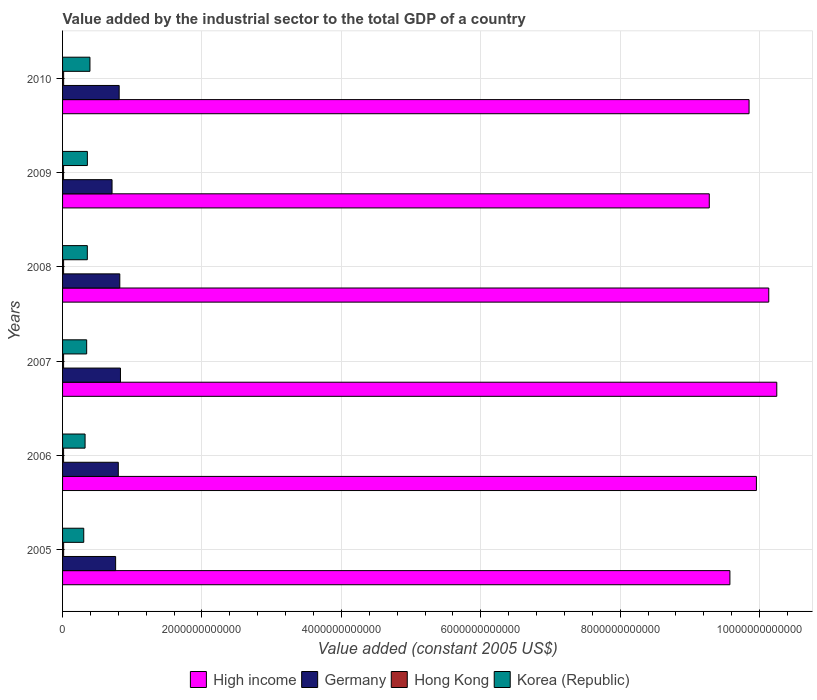How many different coloured bars are there?
Keep it short and to the point. 4. Are the number of bars per tick equal to the number of legend labels?
Provide a succinct answer. Yes. Are the number of bars on each tick of the Y-axis equal?
Your response must be concise. Yes. What is the label of the 4th group of bars from the top?
Your response must be concise. 2007. In how many cases, is the number of bars for a given year not equal to the number of legend labels?
Your response must be concise. 0. What is the value added by the industrial sector in Germany in 2009?
Keep it short and to the point. 7.10e+11. Across all years, what is the maximum value added by the industrial sector in High income?
Offer a terse response. 1.02e+13. Across all years, what is the minimum value added by the industrial sector in High income?
Your answer should be very brief. 9.28e+12. What is the total value added by the industrial sector in Hong Kong in the graph?
Give a very brief answer. 8.97e+1. What is the difference between the value added by the industrial sector in Hong Kong in 2005 and that in 2010?
Keep it short and to the point. -7.29e+07. What is the difference between the value added by the industrial sector in High income in 2009 and the value added by the industrial sector in Hong Kong in 2007?
Keep it short and to the point. 9.26e+12. What is the average value added by the industrial sector in Korea (Republic) per year?
Make the answer very short. 3.46e+11. In the year 2007, what is the difference between the value added by the industrial sector in High income and value added by the industrial sector in Germany?
Give a very brief answer. 9.42e+12. In how many years, is the value added by the industrial sector in Germany greater than 5600000000000 US$?
Provide a short and direct response. 0. What is the ratio of the value added by the industrial sector in Korea (Republic) in 2006 to that in 2008?
Give a very brief answer. 0.91. Is the difference between the value added by the industrial sector in High income in 2007 and 2008 greater than the difference between the value added by the industrial sector in Germany in 2007 and 2008?
Offer a terse response. Yes. What is the difference between the highest and the second highest value added by the industrial sector in High income?
Your answer should be compact. 1.15e+11. What is the difference between the highest and the lowest value added by the industrial sector in High income?
Offer a terse response. 9.68e+11. In how many years, is the value added by the industrial sector in Hong Kong greater than the average value added by the industrial sector in Hong Kong taken over all years?
Offer a terse response. 3. Is the sum of the value added by the industrial sector in Germany in 2008 and 2009 greater than the maximum value added by the industrial sector in Korea (Republic) across all years?
Your response must be concise. Yes. What does the 2nd bar from the top in 2006 represents?
Provide a short and direct response. Hong Kong. What does the 2nd bar from the bottom in 2006 represents?
Your answer should be very brief. Germany. What is the difference between two consecutive major ticks on the X-axis?
Your answer should be compact. 2.00e+12. Are the values on the major ticks of X-axis written in scientific E-notation?
Keep it short and to the point. No. Does the graph contain any zero values?
Make the answer very short. No. Where does the legend appear in the graph?
Offer a very short reply. Bottom center. How many legend labels are there?
Offer a very short reply. 4. What is the title of the graph?
Provide a short and direct response. Value added by the industrial sector to the total GDP of a country. What is the label or title of the X-axis?
Provide a short and direct response. Value added (constant 2005 US$). What is the Value added (constant 2005 US$) in High income in 2005?
Offer a terse response. 9.57e+12. What is the Value added (constant 2005 US$) in Germany in 2005?
Your answer should be very brief. 7.61e+11. What is the Value added (constant 2005 US$) in Hong Kong in 2005?
Make the answer very short. 1.54e+1. What is the Value added (constant 2005 US$) of Korea (Republic) in 2005?
Your answer should be compact. 3.04e+11. What is the Value added (constant 2005 US$) in High income in 2006?
Make the answer very short. 9.95e+12. What is the Value added (constant 2005 US$) of Germany in 2006?
Give a very brief answer. 8.00e+11. What is the Value added (constant 2005 US$) in Hong Kong in 2006?
Give a very brief answer. 1.48e+1. What is the Value added (constant 2005 US$) of Korea (Republic) in 2006?
Ensure brevity in your answer.  3.23e+11. What is the Value added (constant 2005 US$) of High income in 2007?
Keep it short and to the point. 1.02e+13. What is the Value added (constant 2005 US$) of Germany in 2007?
Offer a terse response. 8.31e+11. What is the Value added (constant 2005 US$) in Hong Kong in 2007?
Offer a terse response. 1.48e+1. What is the Value added (constant 2005 US$) of Korea (Republic) in 2007?
Your response must be concise. 3.46e+11. What is the Value added (constant 2005 US$) in High income in 2008?
Your answer should be compact. 1.01e+13. What is the Value added (constant 2005 US$) in Germany in 2008?
Offer a terse response. 8.21e+11. What is the Value added (constant 2005 US$) in Hong Kong in 2008?
Give a very brief answer. 1.51e+1. What is the Value added (constant 2005 US$) of Korea (Republic) in 2008?
Make the answer very short. 3.55e+11. What is the Value added (constant 2005 US$) of High income in 2009?
Offer a terse response. 9.28e+12. What is the Value added (constant 2005 US$) in Germany in 2009?
Offer a very short reply. 7.10e+11. What is the Value added (constant 2005 US$) in Hong Kong in 2009?
Your answer should be very brief. 1.43e+1. What is the Value added (constant 2005 US$) of Korea (Republic) in 2009?
Your response must be concise. 3.56e+11. What is the Value added (constant 2005 US$) of High income in 2010?
Your answer should be very brief. 9.85e+12. What is the Value added (constant 2005 US$) of Germany in 2010?
Offer a terse response. 8.12e+11. What is the Value added (constant 2005 US$) in Hong Kong in 2010?
Provide a succinct answer. 1.54e+1. What is the Value added (constant 2005 US$) in Korea (Republic) in 2010?
Your answer should be very brief. 3.93e+11. Across all years, what is the maximum Value added (constant 2005 US$) in High income?
Ensure brevity in your answer.  1.02e+13. Across all years, what is the maximum Value added (constant 2005 US$) of Germany?
Offer a very short reply. 8.31e+11. Across all years, what is the maximum Value added (constant 2005 US$) in Hong Kong?
Ensure brevity in your answer.  1.54e+1. Across all years, what is the maximum Value added (constant 2005 US$) in Korea (Republic)?
Ensure brevity in your answer.  3.93e+11. Across all years, what is the minimum Value added (constant 2005 US$) in High income?
Your answer should be compact. 9.28e+12. Across all years, what is the minimum Value added (constant 2005 US$) of Germany?
Give a very brief answer. 7.10e+11. Across all years, what is the minimum Value added (constant 2005 US$) of Hong Kong?
Offer a very short reply. 1.43e+1. Across all years, what is the minimum Value added (constant 2005 US$) of Korea (Republic)?
Your response must be concise. 3.04e+11. What is the total Value added (constant 2005 US$) of High income in the graph?
Keep it short and to the point. 5.90e+13. What is the total Value added (constant 2005 US$) in Germany in the graph?
Ensure brevity in your answer.  4.73e+12. What is the total Value added (constant 2005 US$) of Hong Kong in the graph?
Your answer should be very brief. 8.97e+1. What is the total Value added (constant 2005 US$) in Korea (Republic) in the graph?
Give a very brief answer. 2.08e+12. What is the difference between the Value added (constant 2005 US$) in High income in 2005 and that in 2006?
Your answer should be compact. -3.80e+11. What is the difference between the Value added (constant 2005 US$) in Germany in 2005 and that in 2006?
Provide a succinct answer. -3.83e+1. What is the difference between the Value added (constant 2005 US$) of Hong Kong in 2005 and that in 2006?
Your response must be concise. 5.48e+08. What is the difference between the Value added (constant 2005 US$) of Korea (Republic) in 2005 and that in 2006?
Your answer should be compact. -1.90e+1. What is the difference between the Value added (constant 2005 US$) of High income in 2005 and that in 2007?
Your response must be concise. -6.73e+11. What is the difference between the Value added (constant 2005 US$) in Germany in 2005 and that in 2007?
Give a very brief answer. -6.95e+1. What is the difference between the Value added (constant 2005 US$) in Hong Kong in 2005 and that in 2007?
Make the answer very short. 5.95e+08. What is the difference between the Value added (constant 2005 US$) of Korea (Republic) in 2005 and that in 2007?
Your answer should be very brief. -4.20e+1. What is the difference between the Value added (constant 2005 US$) of High income in 2005 and that in 2008?
Provide a short and direct response. -5.58e+11. What is the difference between the Value added (constant 2005 US$) of Germany in 2005 and that in 2008?
Give a very brief answer. -5.98e+1. What is the difference between the Value added (constant 2005 US$) of Hong Kong in 2005 and that in 2008?
Ensure brevity in your answer.  2.79e+08. What is the difference between the Value added (constant 2005 US$) of Korea (Republic) in 2005 and that in 2008?
Offer a terse response. -5.13e+1. What is the difference between the Value added (constant 2005 US$) of High income in 2005 and that in 2009?
Your response must be concise. 2.96e+11. What is the difference between the Value added (constant 2005 US$) in Germany in 2005 and that in 2009?
Offer a very short reply. 5.13e+1. What is the difference between the Value added (constant 2005 US$) in Hong Kong in 2005 and that in 2009?
Give a very brief answer. 1.06e+09. What is the difference between the Value added (constant 2005 US$) of Korea (Republic) in 2005 and that in 2009?
Offer a very short reply. -5.21e+1. What is the difference between the Value added (constant 2005 US$) in High income in 2005 and that in 2010?
Ensure brevity in your answer.  -2.75e+11. What is the difference between the Value added (constant 2005 US$) in Germany in 2005 and that in 2010?
Your response must be concise. -5.10e+1. What is the difference between the Value added (constant 2005 US$) of Hong Kong in 2005 and that in 2010?
Provide a succinct answer. -7.29e+07. What is the difference between the Value added (constant 2005 US$) in Korea (Republic) in 2005 and that in 2010?
Your answer should be very brief. -8.91e+1. What is the difference between the Value added (constant 2005 US$) of High income in 2006 and that in 2007?
Your answer should be very brief. -2.92e+11. What is the difference between the Value added (constant 2005 US$) of Germany in 2006 and that in 2007?
Make the answer very short. -3.12e+1. What is the difference between the Value added (constant 2005 US$) in Hong Kong in 2006 and that in 2007?
Your answer should be very brief. 4.72e+07. What is the difference between the Value added (constant 2005 US$) of Korea (Republic) in 2006 and that in 2007?
Your response must be concise. -2.30e+1. What is the difference between the Value added (constant 2005 US$) of High income in 2006 and that in 2008?
Your answer should be compact. -1.77e+11. What is the difference between the Value added (constant 2005 US$) of Germany in 2006 and that in 2008?
Make the answer very short. -2.15e+1. What is the difference between the Value added (constant 2005 US$) in Hong Kong in 2006 and that in 2008?
Your answer should be very brief. -2.69e+08. What is the difference between the Value added (constant 2005 US$) in Korea (Republic) in 2006 and that in 2008?
Provide a short and direct response. -3.23e+1. What is the difference between the Value added (constant 2005 US$) of High income in 2006 and that in 2009?
Your response must be concise. 6.76e+11. What is the difference between the Value added (constant 2005 US$) of Germany in 2006 and that in 2009?
Offer a very short reply. 8.96e+1. What is the difference between the Value added (constant 2005 US$) of Hong Kong in 2006 and that in 2009?
Provide a succinct answer. 5.16e+08. What is the difference between the Value added (constant 2005 US$) of Korea (Republic) in 2006 and that in 2009?
Offer a very short reply. -3.31e+1. What is the difference between the Value added (constant 2005 US$) in High income in 2006 and that in 2010?
Offer a terse response. 1.05e+11. What is the difference between the Value added (constant 2005 US$) in Germany in 2006 and that in 2010?
Offer a very short reply. -1.27e+1. What is the difference between the Value added (constant 2005 US$) of Hong Kong in 2006 and that in 2010?
Provide a short and direct response. -6.21e+08. What is the difference between the Value added (constant 2005 US$) in Korea (Republic) in 2006 and that in 2010?
Your response must be concise. -7.01e+1. What is the difference between the Value added (constant 2005 US$) in High income in 2007 and that in 2008?
Provide a short and direct response. 1.15e+11. What is the difference between the Value added (constant 2005 US$) of Germany in 2007 and that in 2008?
Your response must be concise. 9.68e+09. What is the difference between the Value added (constant 2005 US$) in Hong Kong in 2007 and that in 2008?
Provide a succinct answer. -3.16e+08. What is the difference between the Value added (constant 2005 US$) in Korea (Republic) in 2007 and that in 2008?
Provide a short and direct response. -9.28e+09. What is the difference between the Value added (constant 2005 US$) of High income in 2007 and that in 2009?
Ensure brevity in your answer.  9.68e+11. What is the difference between the Value added (constant 2005 US$) of Germany in 2007 and that in 2009?
Your answer should be very brief. 1.21e+11. What is the difference between the Value added (constant 2005 US$) of Hong Kong in 2007 and that in 2009?
Give a very brief answer. 4.69e+08. What is the difference between the Value added (constant 2005 US$) in Korea (Republic) in 2007 and that in 2009?
Make the answer very short. -1.01e+1. What is the difference between the Value added (constant 2005 US$) in High income in 2007 and that in 2010?
Make the answer very short. 3.98e+11. What is the difference between the Value added (constant 2005 US$) of Germany in 2007 and that in 2010?
Offer a very short reply. 1.85e+1. What is the difference between the Value added (constant 2005 US$) in Hong Kong in 2007 and that in 2010?
Keep it short and to the point. -6.68e+08. What is the difference between the Value added (constant 2005 US$) of Korea (Republic) in 2007 and that in 2010?
Make the answer very short. -4.71e+1. What is the difference between the Value added (constant 2005 US$) in High income in 2008 and that in 2009?
Make the answer very short. 8.54e+11. What is the difference between the Value added (constant 2005 US$) in Germany in 2008 and that in 2009?
Provide a short and direct response. 1.11e+11. What is the difference between the Value added (constant 2005 US$) of Hong Kong in 2008 and that in 2009?
Offer a terse response. 7.85e+08. What is the difference between the Value added (constant 2005 US$) in Korea (Republic) in 2008 and that in 2009?
Offer a terse response. -8.14e+08. What is the difference between the Value added (constant 2005 US$) of High income in 2008 and that in 2010?
Offer a very short reply. 2.83e+11. What is the difference between the Value added (constant 2005 US$) in Germany in 2008 and that in 2010?
Provide a short and direct response. 8.79e+09. What is the difference between the Value added (constant 2005 US$) in Hong Kong in 2008 and that in 2010?
Offer a terse response. -3.52e+08. What is the difference between the Value added (constant 2005 US$) of Korea (Republic) in 2008 and that in 2010?
Your response must be concise. -3.78e+1. What is the difference between the Value added (constant 2005 US$) of High income in 2009 and that in 2010?
Offer a terse response. -5.71e+11. What is the difference between the Value added (constant 2005 US$) in Germany in 2009 and that in 2010?
Provide a short and direct response. -1.02e+11. What is the difference between the Value added (constant 2005 US$) in Hong Kong in 2009 and that in 2010?
Keep it short and to the point. -1.14e+09. What is the difference between the Value added (constant 2005 US$) of Korea (Republic) in 2009 and that in 2010?
Your response must be concise. -3.70e+1. What is the difference between the Value added (constant 2005 US$) of High income in 2005 and the Value added (constant 2005 US$) of Germany in 2006?
Provide a succinct answer. 8.78e+12. What is the difference between the Value added (constant 2005 US$) of High income in 2005 and the Value added (constant 2005 US$) of Hong Kong in 2006?
Your answer should be compact. 9.56e+12. What is the difference between the Value added (constant 2005 US$) of High income in 2005 and the Value added (constant 2005 US$) of Korea (Republic) in 2006?
Ensure brevity in your answer.  9.25e+12. What is the difference between the Value added (constant 2005 US$) in Germany in 2005 and the Value added (constant 2005 US$) in Hong Kong in 2006?
Offer a very short reply. 7.46e+11. What is the difference between the Value added (constant 2005 US$) of Germany in 2005 and the Value added (constant 2005 US$) of Korea (Republic) in 2006?
Give a very brief answer. 4.38e+11. What is the difference between the Value added (constant 2005 US$) in Hong Kong in 2005 and the Value added (constant 2005 US$) in Korea (Republic) in 2006?
Offer a very short reply. -3.08e+11. What is the difference between the Value added (constant 2005 US$) of High income in 2005 and the Value added (constant 2005 US$) of Germany in 2007?
Your response must be concise. 8.74e+12. What is the difference between the Value added (constant 2005 US$) in High income in 2005 and the Value added (constant 2005 US$) in Hong Kong in 2007?
Make the answer very short. 9.56e+12. What is the difference between the Value added (constant 2005 US$) of High income in 2005 and the Value added (constant 2005 US$) of Korea (Republic) in 2007?
Provide a succinct answer. 9.23e+12. What is the difference between the Value added (constant 2005 US$) of Germany in 2005 and the Value added (constant 2005 US$) of Hong Kong in 2007?
Provide a succinct answer. 7.46e+11. What is the difference between the Value added (constant 2005 US$) of Germany in 2005 and the Value added (constant 2005 US$) of Korea (Republic) in 2007?
Give a very brief answer. 4.15e+11. What is the difference between the Value added (constant 2005 US$) of Hong Kong in 2005 and the Value added (constant 2005 US$) of Korea (Republic) in 2007?
Your answer should be compact. -3.31e+11. What is the difference between the Value added (constant 2005 US$) of High income in 2005 and the Value added (constant 2005 US$) of Germany in 2008?
Keep it short and to the point. 8.75e+12. What is the difference between the Value added (constant 2005 US$) of High income in 2005 and the Value added (constant 2005 US$) of Hong Kong in 2008?
Your response must be concise. 9.56e+12. What is the difference between the Value added (constant 2005 US$) in High income in 2005 and the Value added (constant 2005 US$) in Korea (Republic) in 2008?
Offer a very short reply. 9.22e+12. What is the difference between the Value added (constant 2005 US$) of Germany in 2005 and the Value added (constant 2005 US$) of Hong Kong in 2008?
Your answer should be very brief. 7.46e+11. What is the difference between the Value added (constant 2005 US$) of Germany in 2005 and the Value added (constant 2005 US$) of Korea (Republic) in 2008?
Provide a succinct answer. 4.06e+11. What is the difference between the Value added (constant 2005 US$) in Hong Kong in 2005 and the Value added (constant 2005 US$) in Korea (Republic) in 2008?
Offer a very short reply. -3.40e+11. What is the difference between the Value added (constant 2005 US$) of High income in 2005 and the Value added (constant 2005 US$) of Germany in 2009?
Your answer should be compact. 8.86e+12. What is the difference between the Value added (constant 2005 US$) in High income in 2005 and the Value added (constant 2005 US$) in Hong Kong in 2009?
Keep it short and to the point. 9.56e+12. What is the difference between the Value added (constant 2005 US$) of High income in 2005 and the Value added (constant 2005 US$) of Korea (Republic) in 2009?
Offer a very short reply. 9.22e+12. What is the difference between the Value added (constant 2005 US$) of Germany in 2005 and the Value added (constant 2005 US$) of Hong Kong in 2009?
Give a very brief answer. 7.47e+11. What is the difference between the Value added (constant 2005 US$) of Germany in 2005 and the Value added (constant 2005 US$) of Korea (Republic) in 2009?
Give a very brief answer. 4.05e+11. What is the difference between the Value added (constant 2005 US$) in Hong Kong in 2005 and the Value added (constant 2005 US$) in Korea (Republic) in 2009?
Provide a succinct answer. -3.41e+11. What is the difference between the Value added (constant 2005 US$) of High income in 2005 and the Value added (constant 2005 US$) of Germany in 2010?
Offer a very short reply. 8.76e+12. What is the difference between the Value added (constant 2005 US$) in High income in 2005 and the Value added (constant 2005 US$) in Hong Kong in 2010?
Your answer should be compact. 9.56e+12. What is the difference between the Value added (constant 2005 US$) in High income in 2005 and the Value added (constant 2005 US$) in Korea (Republic) in 2010?
Make the answer very short. 9.18e+12. What is the difference between the Value added (constant 2005 US$) of Germany in 2005 and the Value added (constant 2005 US$) of Hong Kong in 2010?
Ensure brevity in your answer.  7.46e+11. What is the difference between the Value added (constant 2005 US$) of Germany in 2005 and the Value added (constant 2005 US$) of Korea (Republic) in 2010?
Ensure brevity in your answer.  3.68e+11. What is the difference between the Value added (constant 2005 US$) of Hong Kong in 2005 and the Value added (constant 2005 US$) of Korea (Republic) in 2010?
Your response must be concise. -3.78e+11. What is the difference between the Value added (constant 2005 US$) of High income in 2006 and the Value added (constant 2005 US$) of Germany in 2007?
Offer a very short reply. 9.12e+12. What is the difference between the Value added (constant 2005 US$) of High income in 2006 and the Value added (constant 2005 US$) of Hong Kong in 2007?
Ensure brevity in your answer.  9.94e+12. What is the difference between the Value added (constant 2005 US$) in High income in 2006 and the Value added (constant 2005 US$) in Korea (Republic) in 2007?
Provide a short and direct response. 9.61e+12. What is the difference between the Value added (constant 2005 US$) in Germany in 2006 and the Value added (constant 2005 US$) in Hong Kong in 2007?
Keep it short and to the point. 7.85e+11. What is the difference between the Value added (constant 2005 US$) in Germany in 2006 and the Value added (constant 2005 US$) in Korea (Republic) in 2007?
Ensure brevity in your answer.  4.54e+11. What is the difference between the Value added (constant 2005 US$) of Hong Kong in 2006 and the Value added (constant 2005 US$) of Korea (Republic) in 2007?
Give a very brief answer. -3.31e+11. What is the difference between the Value added (constant 2005 US$) of High income in 2006 and the Value added (constant 2005 US$) of Germany in 2008?
Give a very brief answer. 9.13e+12. What is the difference between the Value added (constant 2005 US$) in High income in 2006 and the Value added (constant 2005 US$) in Hong Kong in 2008?
Make the answer very short. 9.94e+12. What is the difference between the Value added (constant 2005 US$) in High income in 2006 and the Value added (constant 2005 US$) in Korea (Republic) in 2008?
Ensure brevity in your answer.  9.60e+12. What is the difference between the Value added (constant 2005 US$) in Germany in 2006 and the Value added (constant 2005 US$) in Hong Kong in 2008?
Ensure brevity in your answer.  7.84e+11. What is the difference between the Value added (constant 2005 US$) of Germany in 2006 and the Value added (constant 2005 US$) of Korea (Republic) in 2008?
Your answer should be compact. 4.44e+11. What is the difference between the Value added (constant 2005 US$) in Hong Kong in 2006 and the Value added (constant 2005 US$) in Korea (Republic) in 2008?
Provide a short and direct response. -3.40e+11. What is the difference between the Value added (constant 2005 US$) of High income in 2006 and the Value added (constant 2005 US$) of Germany in 2009?
Make the answer very short. 9.24e+12. What is the difference between the Value added (constant 2005 US$) of High income in 2006 and the Value added (constant 2005 US$) of Hong Kong in 2009?
Provide a short and direct response. 9.94e+12. What is the difference between the Value added (constant 2005 US$) of High income in 2006 and the Value added (constant 2005 US$) of Korea (Republic) in 2009?
Give a very brief answer. 9.60e+12. What is the difference between the Value added (constant 2005 US$) in Germany in 2006 and the Value added (constant 2005 US$) in Hong Kong in 2009?
Your answer should be compact. 7.85e+11. What is the difference between the Value added (constant 2005 US$) in Germany in 2006 and the Value added (constant 2005 US$) in Korea (Republic) in 2009?
Offer a terse response. 4.43e+11. What is the difference between the Value added (constant 2005 US$) of Hong Kong in 2006 and the Value added (constant 2005 US$) of Korea (Republic) in 2009?
Offer a terse response. -3.41e+11. What is the difference between the Value added (constant 2005 US$) of High income in 2006 and the Value added (constant 2005 US$) of Germany in 2010?
Your response must be concise. 9.14e+12. What is the difference between the Value added (constant 2005 US$) of High income in 2006 and the Value added (constant 2005 US$) of Hong Kong in 2010?
Offer a terse response. 9.94e+12. What is the difference between the Value added (constant 2005 US$) in High income in 2006 and the Value added (constant 2005 US$) in Korea (Republic) in 2010?
Your response must be concise. 9.56e+12. What is the difference between the Value added (constant 2005 US$) of Germany in 2006 and the Value added (constant 2005 US$) of Hong Kong in 2010?
Provide a succinct answer. 7.84e+11. What is the difference between the Value added (constant 2005 US$) of Germany in 2006 and the Value added (constant 2005 US$) of Korea (Republic) in 2010?
Your answer should be compact. 4.06e+11. What is the difference between the Value added (constant 2005 US$) in Hong Kong in 2006 and the Value added (constant 2005 US$) in Korea (Republic) in 2010?
Give a very brief answer. -3.78e+11. What is the difference between the Value added (constant 2005 US$) of High income in 2007 and the Value added (constant 2005 US$) of Germany in 2008?
Offer a very short reply. 9.43e+12. What is the difference between the Value added (constant 2005 US$) of High income in 2007 and the Value added (constant 2005 US$) of Hong Kong in 2008?
Provide a short and direct response. 1.02e+13. What is the difference between the Value added (constant 2005 US$) in High income in 2007 and the Value added (constant 2005 US$) in Korea (Republic) in 2008?
Your answer should be very brief. 9.89e+12. What is the difference between the Value added (constant 2005 US$) of Germany in 2007 and the Value added (constant 2005 US$) of Hong Kong in 2008?
Keep it short and to the point. 8.16e+11. What is the difference between the Value added (constant 2005 US$) of Germany in 2007 and the Value added (constant 2005 US$) of Korea (Republic) in 2008?
Offer a very short reply. 4.75e+11. What is the difference between the Value added (constant 2005 US$) of Hong Kong in 2007 and the Value added (constant 2005 US$) of Korea (Republic) in 2008?
Make the answer very short. -3.40e+11. What is the difference between the Value added (constant 2005 US$) of High income in 2007 and the Value added (constant 2005 US$) of Germany in 2009?
Ensure brevity in your answer.  9.54e+12. What is the difference between the Value added (constant 2005 US$) of High income in 2007 and the Value added (constant 2005 US$) of Hong Kong in 2009?
Your answer should be very brief. 1.02e+13. What is the difference between the Value added (constant 2005 US$) in High income in 2007 and the Value added (constant 2005 US$) in Korea (Republic) in 2009?
Provide a short and direct response. 9.89e+12. What is the difference between the Value added (constant 2005 US$) in Germany in 2007 and the Value added (constant 2005 US$) in Hong Kong in 2009?
Ensure brevity in your answer.  8.16e+11. What is the difference between the Value added (constant 2005 US$) in Germany in 2007 and the Value added (constant 2005 US$) in Korea (Republic) in 2009?
Your answer should be compact. 4.75e+11. What is the difference between the Value added (constant 2005 US$) of Hong Kong in 2007 and the Value added (constant 2005 US$) of Korea (Republic) in 2009?
Your answer should be very brief. -3.41e+11. What is the difference between the Value added (constant 2005 US$) of High income in 2007 and the Value added (constant 2005 US$) of Germany in 2010?
Ensure brevity in your answer.  9.43e+12. What is the difference between the Value added (constant 2005 US$) of High income in 2007 and the Value added (constant 2005 US$) of Hong Kong in 2010?
Provide a succinct answer. 1.02e+13. What is the difference between the Value added (constant 2005 US$) in High income in 2007 and the Value added (constant 2005 US$) in Korea (Republic) in 2010?
Offer a terse response. 9.85e+12. What is the difference between the Value added (constant 2005 US$) in Germany in 2007 and the Value added (constant 2005 US$) in Hong Kong in 2010?
Keep it short and to the point. 8.15e+11. What is the difference between the Value added (constant 2005 US$) of Germany in 2007 and the Value added (constant 2005 US$) of Korea (Republic) in 2010?
Offer a very short reply. 4.38e+11. What is the difference between the Value added (constant 2005 US$) in Hong Kong in 2007 and the Value added (constant 2005 US$) in Korea (Republic) in 2010?
Offer a very short reply. -3.78e+11. What is the difference between the Value added (constant 2005 US$) in High income in 2008 and the Value added (constant 2005 US$) in Germany in 2009?
Your response must be concise. 9.42e+12. What is the difference between the Value added (constant 2005 US$) of High income in 2008 and the Value added (constant 2005 US$) of Hong Kong in 2009?
Ensure brevity in your answer.  1.01e+13. What is the difference between the Value added (constant 2005 US$) of High income in 2008 and the Value added (constant 2005 US$) of Korea (Republic) in 2009?
Your answer should be very brief. 9.78e+12. What is the difference between the Value added (constant 2005 US$) in Germany in 2008 and the Value added (constant 2005 US$) in Hong Kong in 2009?
Make the answer very short. 8.07e+11. What is the difference between the Value added (constant 2005 US$) in Germany in 2008 and the Value added (constant 2005 US$) in Korea (Republic) in 2009?
Keep it short and to the point. 4.65e+11. What is the difference between the Value added (constant 2005 US$) in Hong Kong in 2008 and the Value added (constant 2005 US$) in Korea (Republic) in 2009?
Offer a terse response. -3.41e+11. What is the difference between the Value added (constant 2005 US$) in High income in 2008 and the Value added (constant 2005 US$) in Germany in 2010?
Ensure brevity in your answer.  9.32e+12. What is the difference between the Value added (constant 2005 US$) in High income in 2008 and the Value added (constant 2005 US$) in Hong Kong in 2010?
Your answer should be very brief. 1.01e+13. What is the difference between the Value added (constant 2005 US$) of High income in 2008 and the Value added (constant 2005 US$) of Korea (Republic) in 2010?
Give a very brief answer. 9.74e+12. What is the difference between the Value added (constant 2005 US$) in Germany in 2008 and the Value added (constant 2005 US$) in Hong Kong in 2010?
Your answer should be very brief. 8.06e+11. What is the difference between the Value added (constant 2005 US$) of Germany in 2008 and the Value added (constant 2005 US$) of Korea (Republic) in 2010?
Your answer should be very brief. 4.28e+11. What is the difference between the Value added (constant 2005 US$) of Hong Kong in 2008 and the Value added (constant 2005 US$) of Korea (Republic) in 2010?
Your answer should be very brief. -3.78e+11. What is the difference between the Value added (constant 2005 US$) of High income in 2009 and the Value added (constant 2005 US$) of Germany in 2010?
Your answer should be very brief. 8.47e+12. What is the difference between the Value added (constant 2005 US$) of High income in 2009 and the Value added (constant 2005 US$) of Hong Kong in 2010?
Offer a terse response. 9.26e+12. What is the difference between the Value added (constant 2005 US$) in High income in 2009 and the Value added (constant 2005 US$) in Korea (Republic) in 2010?
Provide a succinct answer. 8.89e+12. What is the difference between the Value added (constant 2005 US$) in Germany in 2009 and the Value added (constant 2005 US$) in Hong Kong in 2010?
Give a very brief answer. 6.94e+11. What is the difference between the Value added (constant 2005 US$) in Germany in 2009 and the Value added (constant 2005 US$) in Korea (Republic) in 2010?
Keep it short and to the point. 3.17e+11. What is the difference between the Value added (constant 2005 US$) in Hong Kong in 2009 and the Value added (constant 2005 US$) in Korea (Republic) in 2010?
Keep it short and to the point. -3.79e+11. What is the average Value added (constant 2005 US$) in High income per year?
Your response must be concise. 9.84e+12. What is the average Value added (constant 2005 US$) of Germany per year?
Provide a short and direct response. 7.89e+11. What is the average Value added (constant 2005 US$) of Hong Kong per year?
Offer a terse response. 1.50e+1. What is the average Value added (constant 2005 US$) of Korea (Republic) per year?
Offer a terse response. 3.46e+11. In the year 2005, what is the difference between the Value added (constant 2005 US$) of High income and Value added (constant 2005 US$) of Germany?
Provide a short and direct response. 8.81e+12. In the year 2005, what is the difference between the Value added (constant 2005 US$) of High income and Value added (constant 2005 US$) of Hong Kong?
Ensure brevity in your answer.  9.56e+12. In the year 2005, what is the difference between the Value added (constant 2005 US$) of High income and Value added (constant 2005 US$) of Korea (Republic)?
Offer a very short reply. 9.27e+12. In the year 2005, what is the difference between the Value added (constant 2005 US$) of Germany and Value added (constant 2005 US$) of Hong Kong?
Provide a short and direct response. 7.46e+11. In the year 2005, what is the difference between the Value added (constant 2005 US$) in Germany and Value added (constant 2005 US$) in Korea (Republic)?
Your answer should be very brief. 4.57e+11. In the year 2005, what is the difference between the Value added (constant 2005 US$) of Hong Kong and Value added (constant 2005 US$) of Korea (Republic)?
Provide a succinct answer. -2.89e+11. In the year 2006, what is the difference between the Value added (constant 2005 US$) in High income and Value added (constant 2005 US$) in Germany?
Ensure brevity in your answer.  9.16e+12. In the year 2006, what is the difference between the Value added (constant 2005 US$) of High income and Value added (constant 2005 US$) of Hong Kong?
Make the answer very short. 9.94e+12. In the year 2006, what is the difference between the Value added (constant 2005 US$) of High income and Value added (constant 2005 US$) of Korea (Republic)?
Your response must be concise. 9.63e+12. In the year 2006, what is the difference between the Value added (constant 2005 US$) of Germany and Value added (constant 2005 US$) of Hong Kong?
Your answer should be very brief. 7.85e+11. In the year 2006, what is the difference between the Value added (constant 2005 US$) in Germany and Value added (constant 2005 US$) in Korea (Republic)?
Your answer should be compact. 4.77e+11. In the year 2006, what is the difference between the Value added (constant 2005 US$) in Hong Kong and Value added (constant 2005 US$) in Korea (Republic)?
Your response must be concise. -3.08e+11. In the year 2007, what is the difference between the Value added (constant 2005 US$) in High income and Value added (constant 2005 US$) in Germany?
Give a very brief answer. 9.42e+12. In the year 2007, what is the difference between the Value added (constant 2005 US$) in High income and Value added (constant 2005 US$) in Hong Kong?
Offer a very short reply. 1.02e+13. In the year 2007, what is the difference between the Value added (constant 2005 US$) in High income and Value added (constant 2005 US$) in Korea (Republic)?
Give a very brief answer. 9.90e+12. In the year 2007, what is the difference between the Value added (constant 2005 US$) of Germany and Value added (constant 2005 US$) of Hong Kong?
Keep it short and to the point. 8.16e+11. In the year 2007, what is the difference between the Value added (constant 2005 US$) in Germany and Value added (constant 2005 US$) in Korea (Republic)?
Your answer should be compact. 4.85e+11. In the year 2007, what is the difference between the Value added (constant 2005 US$) of Hong Kong and Value added (constant 2005 US$) of Korea (Republic)?
Your answer should be very brief. -3.31e+11. In the year 2008, what is the difference between the Value added (constant 2005 US$) of High income and Value added (constant 2005 US$) of Germany?
Your response must be concise. 9.31e+12. In the year 2008, what is the difference between the Value added (constant 2005 US$) in High income and Value added (constant 2005 US$) in Hong Kong?
Make the answer very short. 1.01e+13. In the year 2008, what is the difference between the Value added (constant 2005 US$) in High income and Value added (constant 2005 US$) in Korea (Republic)?
Ensure brevity in your answer.  9.78e+12. In the year 2008, what is the difference between the Value added (constant 2005 US$) in Germany and Value added (constant 2005 US$) in Hong Kong?
Your response must be concise. 8.06e+11. In the year 2008, what is the difference between the Value added (constant 2005 US$) in Germany and Value added (constant 2005 US$) in Korea (Republic)?
Provide a short and direct response. 4.66e+11. In the year 2008, what is the difference between the Value added (constant 2005 US$) in Hong Kong and Value added (constant 2005 US$) in Korea (Republic)?
Offer a terse response. -3.40e+11. In the year 2009, what is the difference between the Value added (constant 2005 US$) of High income and Value added (constant 2005 US$) of Germany?
Give a very brief answer. 8.57e+12. In the year 2009, what is the difference between the Value added (constant 2005 US$) in High income and Value added (constant 2005 US$) in Hong Kong?
Your answer should be compact. 9.26e+12. In the year 2009, what is the difference between the Value added (constant 2005 US$) of High income and Value added (constant 2005 US$) of Korea (Republic)?
Offer a very short reply. 8.92e+12. In the year 2009, what is the difference between the Value added (constant 2005 US$) of Germany and Value added (constant 2005 US$) of Hong Kong?
Your answer should be very brief. 6.96e+11. In the year 2009, what is the difference between the Value added (constant 2005 US$) in Germany and Value added (constant 2005 US$) in Korea (Republic)?
Provide a succinct answer. 3.54e+11. In the year 2009, what is the difference between the Value added (constant 2005 US$) of Hong Kong and Value added (constant 2005 US$) of Korea (Republic)?
Ensure brevity in your answer.  -3.42e+11. In the year 2010, what is the difference between the Value added (constant 2005 US$) of High income and Value added (constant 2005 US$) of Germany?
Provide a short and direct response. 9.04e+12. In the year 2010, what is the difference between the Value added (constant 2005 US$) of High income and Value added (constant 2005 US$) of Hong Kong?
Offer a terse response. 9.83e+12. In the year 2010, what is the difference between the Value added (constant 2005 US$) in High income and Value added (constant 2005 US$) in Korea (Republic)?
Your answer should be very brief. 9.46e+12. In the year 2010, what is the difference between the Value added (constant 2005 US$) in Germany and Value added (constant 2005 US$) in Hong Kong?
Your response must be concise. 7.97e+11. In the year 2010, what is the difference between the Value added (constant 2005 US$) of Germany and Value added (constant 2005 US$) of Korea (Republic)?
Offer a terse response. 4.19e+11. In the year 2010, what is the difference between the Value added (constant 2005 US$) in Hong Kong and Value added (constant 2005 US$) in Korea (Republic)?
Provide a short and direct response. -3.78e+11. What is the ratio of the Value added (constant 2005 US$) of High income in 2005 to that in 2006?
Provide a short and direct response. 0.96. What is the ratio of the Value added (constant 2005 US$) in Germany in 2005 to that in 2006?
Give a very brief answer. 0.95. What is the ratio of the Value added (constant 2005 US$) of Korea (Republic) in 2005 to that in 2006?
Offer a terse response. 0.94. What is the ratio of the Value added (constant 2005 US$) of High income in 2005 to that in 2007?
Offer a terse response. 0.93. What is the ratio of the Value added (constant 2005 US$) of Germany in 2005 to that in 2007?
Give a very brief answer. 0.92. What is the ratio of the Value added (constant 2005 US$) in Hong Kong in 2005 to that in 2007?
Your response must be concise. 1.04. What is the ratio of the Value added (constant 2005 US$) in Korea (Republic) in 2005 to that in 2007?
Make the answer very short. 0.88. What is the ratio of the Value added (constant 2005 US$) of High income in 2005 to that in 2008?
Make the answer very short. 0.94. What is the ratio of the Value added (constant 2005 US$) of Germany in 2005 to that in 2008?
Your answer should be very brief. 0.93. What is the ratio of the Value added (constant 2005 US$) in Hong Kong in 2005 to that in 2008?
Make the answer very short. 1.02. What is the ratio of the Value added (constant 2005 US$) of Korea (Republic) in 2005 to that in 2008?
Give a very brief answer. 0.86. What is the ratio of the Value added (constant 2005 US$) in High income in 2005 to that in 2009?
Ensure brevity in your answer.  1.03. What is the ratio of the Value added (constant 2005 US$) in Germany in 2005 to that in 2009?
Your answer should be compact. 1.07. What is the ratio of the Value added (constant 2005 US$) of Hong Kong in 2005 to that in 2009?
Give a very brief answer. 1.07. What is the ratio of the Value added (constant 2005 US$) of Korea (Republic) in 2005 to that in 2009?
Your answer should be compact. 0.85. What is the ratio of the Value added (constant 2005 US$) of High income in 2005 to that in 2010?
Make the answer very short. 0.97. What is the ratio of the Value added (constant 2005 US$) of Germany in 2005 to that in 2010?
Ensure brevity in your answer.  0.94. What is the ratio of the Value added (constant 2005 US$) in Korea (Republic) in 2005 to that in 2010?
Make the answer very short. 0.77. What is the ratio of the Value added (constant 2005 US$) of High income in 2006 to that in 2007?
Ensure brevity in your answer.  0.97. What is the ratio of the Value added (constant 2005 US$) of Germany in 2006 to that in 2007?
Provide a short and direct response. 0.96. What is the ratio of the Value added (constant 2005 US$) in Hong Kong in 2006 to that in 2007?
Your response must be concise. 1. What is the ratio of the Value added (constant 2005 US$) in Korea (Republic) in 2006 to that in 2007?
Provide a succinct answer. 0.93. What is the ratio of the Value added (constant 2005 US$) of High income in 2006 to that in 2008?
Provide a succinct answer. 0.98. What is the ratio of the Value added (constant 2005 US$) of Germany in 2006 to that in 2008?
Your response must be concise. 0.97. What is the ratio of the Value added (constant 2005 US$) in Hong Kong in 2006 to that in 2008?
Offer a very short reply. 0.98. What is the ratio of the Value added (constant 2005 US$) in High income in 2006 to that in 2009?
Give a very brief answer. 1.07. What is the ratio of the Value added (constant 2005 US$) in Germany in 2006 to that in 2009?
Ensure brevity in your answer.  1.13. What is the ratio of the Value added (constant 2005 US$) in Hong Kong in 2006 to that in 2009?
Your response must be concise. 1.04. What is the ratio of the Value added (constant 2005 US$) of Korea (Republic) in 2006 to that in 2009?
Offer a terse response. 0.91. What is the ratio of the Value added (constant 2005 US$) of High income in 2006 to that in 2010?
Provide a succinct answer. 1.01. What is the ratio of the Value added (constant 2005 US$) of Germany in 2006 to that in 2010?
Keep it short and to the point. 0.98. What is the ratio of the Value added (constant 2005 US$) of Hong Kong in 2006 to that in 2010?
Make the answer very short. 0.96. What is the ratio of the Value added (constant 2005 US$) in Korea (Republic) in 2006 to that in 2010?
Give a very brief answer. 0.82. What is the ratio of the Value added (constant 2005 US$) in High income in 2007 to that in 2008?
Offer a very short reply. 1.01. What is the ratio of the Value added (constant 2005 US$) of Germany in 2007 to that in 2008?
Ensure brevity in your answer.  1.01. What is the ratio of the Value added (constant 2005 US$) in Hong Kong in 2007 to that in 2008?
Provide a short and direct response. 0.98. What is the ratio of the Value added (constant 2005 US$) of Korea (Republic) in 2007 to that in 2008?
Offer a very short reply. 0.97. What is the ratio of the Value added (constant 2005 US$) in High income in 2007 to that in 2009?
Offer a terse response. 1.1. What is the ratio of the Value added (constant 2005 US$) of Germany in 2007 to that in 2009?
Make the answer very short. 1.17. What is the ratio of the Value added (constant 2005 US$) in Hong Kong in 2007 to that in 2009?
Keep it short and to the point. 1.03. What is the ratio of the Value added (constant 2005 US$) of Korea (Republic) in 2007 to that in 2009?
Keep it short and to the point. 0.97. What is the ratio of the Value added (constant 2005 US$) in High income in 2007 to that in 2010?
Provide a short and direct response. 1.04. What is the ratio of the Value added (constant 2005 US$) of Germany in 2007 to that in 2010?
Provide a succinct answer. 1.02. What is the ratio of the Value added (constant 2005 US$) in Hong Kong in 2007 to that in 2010?
Ensure brevity in your answer.  0.96. What is the ratio of the Value added (constant 2005 US$) in Korea (Republic) in 2007 to that in 2010?
Keep it short and to the point. 0.88. What is the ratio of the Value added (constant 2005 US$) in High income in 2008 to that in 2009?
Keep it short and to the point. 1.09. What is the ratio of the Value added (constant 2005 US$) in Germany in 2008 to that in 2009?
Make the answer very short. 1.16. What is the ratio of the Value added (constant 2005 US$) of Hong Kong in 2008 to that in 2009?
Your response must be concise. 1.05. What is the ratio of the Value added (constant 2005 US$) of Korea (Republic) in 2008 to that in 2009?
Keep it short and to the point. 1. What is the ratio of the Value added (constant 2005 US$) in High income in 2008 to that in 2010?
Your answer should be compact. 1.03. What is the ratio of the Value added (constant 2005 US$) of Germany in 2008 to that in 2010?
Provide a succinct answer. 1.01. What is the ratio of the Value added (constant 2005 US$) of Hong Kong in 2008 to that in 2010?
Give a very brief answer. 0.98. What is the ratio of the Value added (constant 2005 US$) in Korea (Republic) in 2008 to that in 2010?
Provide a short and direct response. 0.9. What is the ratio of the Value added (constant 2005 US$) in High income in 2009 to that in 2010?
Provide a short and direct response. 0.94. What is the ratio of the Value added (constant 2005 US$) of Germany in 2009 to that in 2010?
Your answer should be compact. 0.87. What is the ratio of the Value added (constant 2005 US$) in Hong Kong in 2009 to that in 2010?
Offer a very short reply. 0.93. What is the ratio of the Value added (constant 2005 US$) of Korea (Republic) in 2009 to that in 2010?
Your answer should be compact. 0.91. What is the difference between the highest and the second highest Value added (constant 2005 US$) of High income?
Provide a short and direct response. 1.15e+11. What is the difference between the highest and the second highest Value added (constant 2005 US$) in Germany?
Keep it short and to the point. 9.68e+09. What is the difference between the highest and the second highest Value added (constant 2005 US$) in Hong Kong?
Your response must be concise. 7.29e+07. What is the difference between the highest and the second highest Value added (constant 2005 US$) in Korea (Republic)?
Your answer should be very brief. 3.70e+1. What is the difference between the highest and the lowest Value added (constant 2005 US$) in High income?
Give a very brief answer. 9.68e+11. What is the difference between the highest and the lowest Value added (constant 2005 US$) in Germany?
Your response must be concise. 1.21e+11. What is the difference between the highest and the lowest Value added (constant 2005 US$) of Hong Kong?
Ensure brevity in your answer.  1.14e+09. What is the difference between the highest and the lowest Value added (constant 2005 US$) in Korea (Republic)?
Offer a terse response. 8.91e+1. 